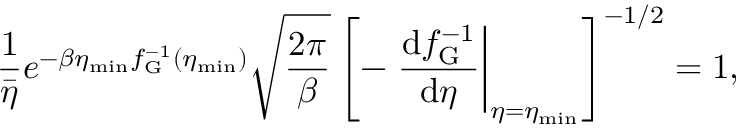Convert formula to latex. <formula><loc_0><loc_0><loc_500><loc_500>\frac { 1 } { \bar { \eta } } e ^ { - \beta \eta _ { \min } f _ { G } ^ { - 1 } ( \eta _ { \min } ) } \sqrt { \frac { 2 \pi } { \beta } } \left [ - \frac { d f _ { G } ^ { - 1 } } { d \eta } \right | _ { \eta = \eta _ { \min } } \right ] ^ { - 1 / 2 } = 1 ,</formula> 